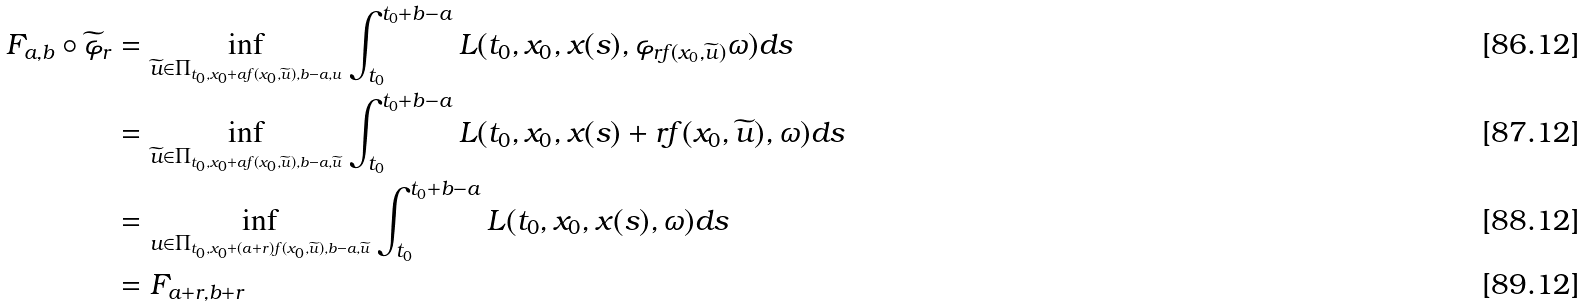Convert formula to latex. <formula><loc_0><loc_0><loc_500><loc_500>F _ { a , b } \circ \widetilde { \varphi } _ { r } & = \inf _ { \widetilde { u } \in \Pi _ { t _ { 0 } , x _ { 0 } + a f ( x _ { 0 } , \widetilde { u } ) , b - a , u } } \int _ { t _ { 0 } } ^ { t _ { 0 } + b - a } L ( t _ { 0 } , x _ { 0 } , x ( s ) , \varphi _ { r f ( x _ { 0 } , \widetilde { u } ) } \omega ) d s \\ & = \inf _ { \widetilde { u } \in \Pi _ { t _ { 0 } , x _ { 0 } + a f ( x _ { 0 } , \widetilde { u } ) , b - a , \widetilde { u } } } \int _ { t _ { 0 } } ^ { t _ { 0 } + b - a } L ( t _ { 0 } , x _ { 0 } , x ( s ) + r f ( x _ { 0 } , \widetilde { u } ) , \omega ) d s \\ & = \inf _ { u \in \Pi _ { t _ { 0 } , x _ { 0 } + ( a + r ) f ( x _ { 0 } , \widetilde { u } ) , b - a , \widetilde { u } } } \int _ { t _ { 0 } } ^ { t _ { 0 } + b - a } L ( t _ { 0 } , x _ { 0 } , x ( s ) , \omega ) d s \\ & = F _ { a + r , b + r }</formula> 